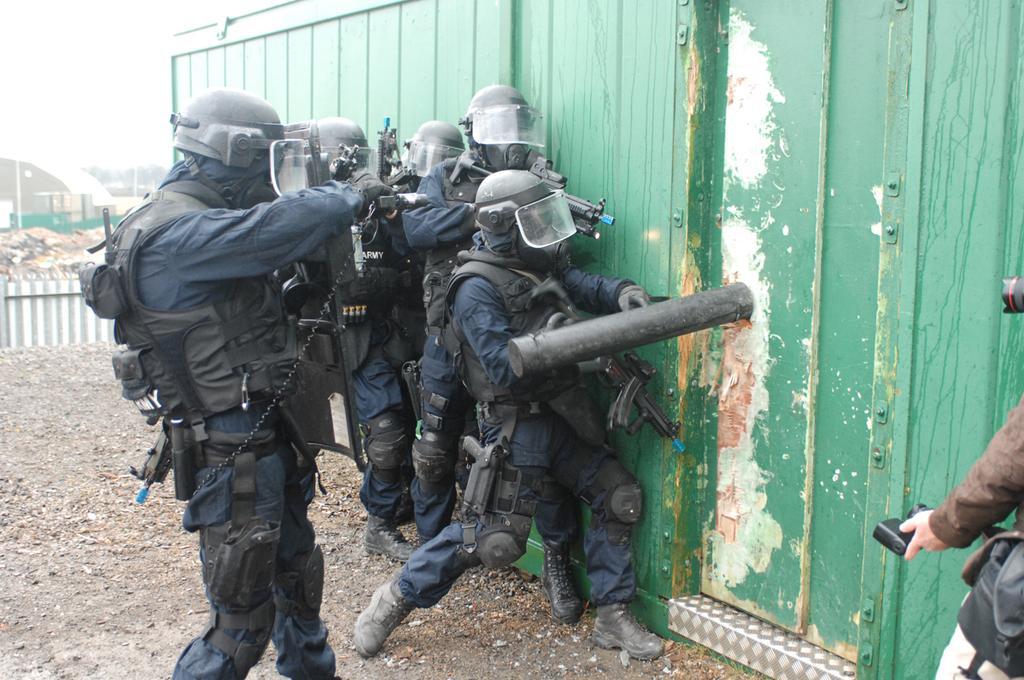Could you give a brief overview of what you see in this image? In this image we can see a few people holding guns, also we can see the wall, doors, trees and poles, in the background we can see the sky. 